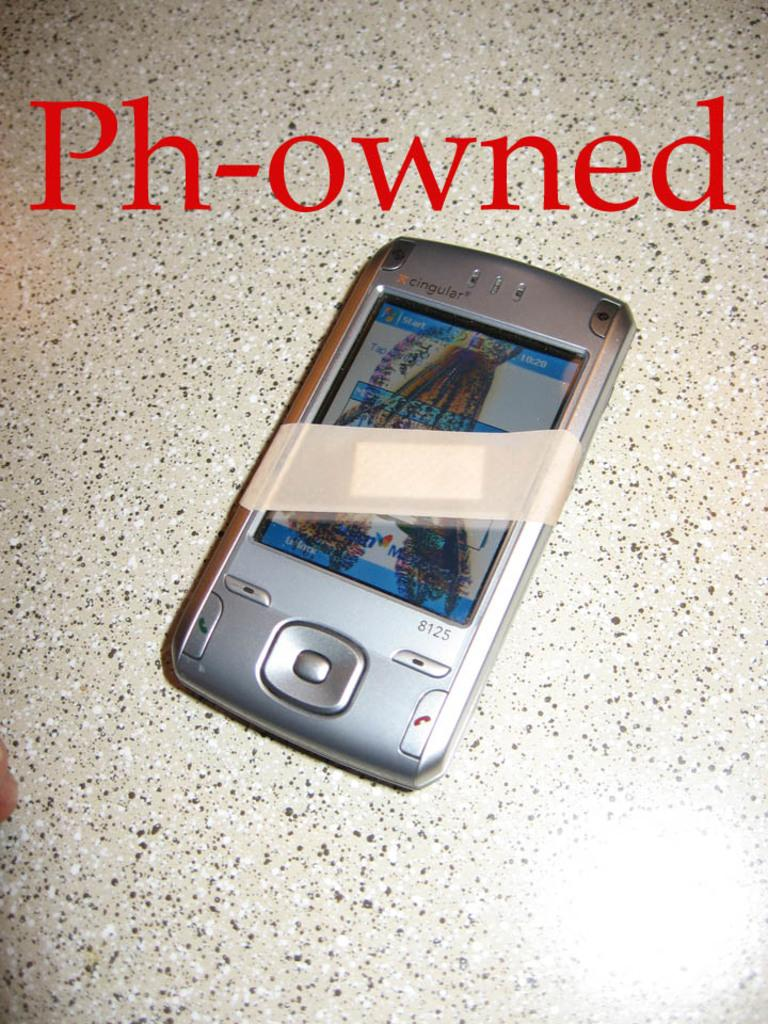<image>
Render a clear and concise summary of the photo. The quirky title Ph-owned is shown above this mobile device. 